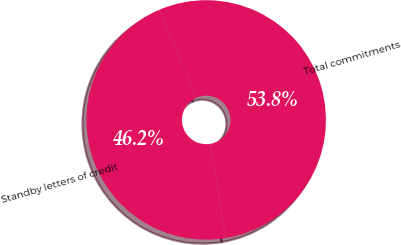Convert chart to OTSL. <chart><loc_0><loc_0><loc_500><loc_500><pie_chart><fcel>Standby letters of credit<fcel>Total commitments<nl><fcel>46.17%<fcel>53.83%<nl></chart> 